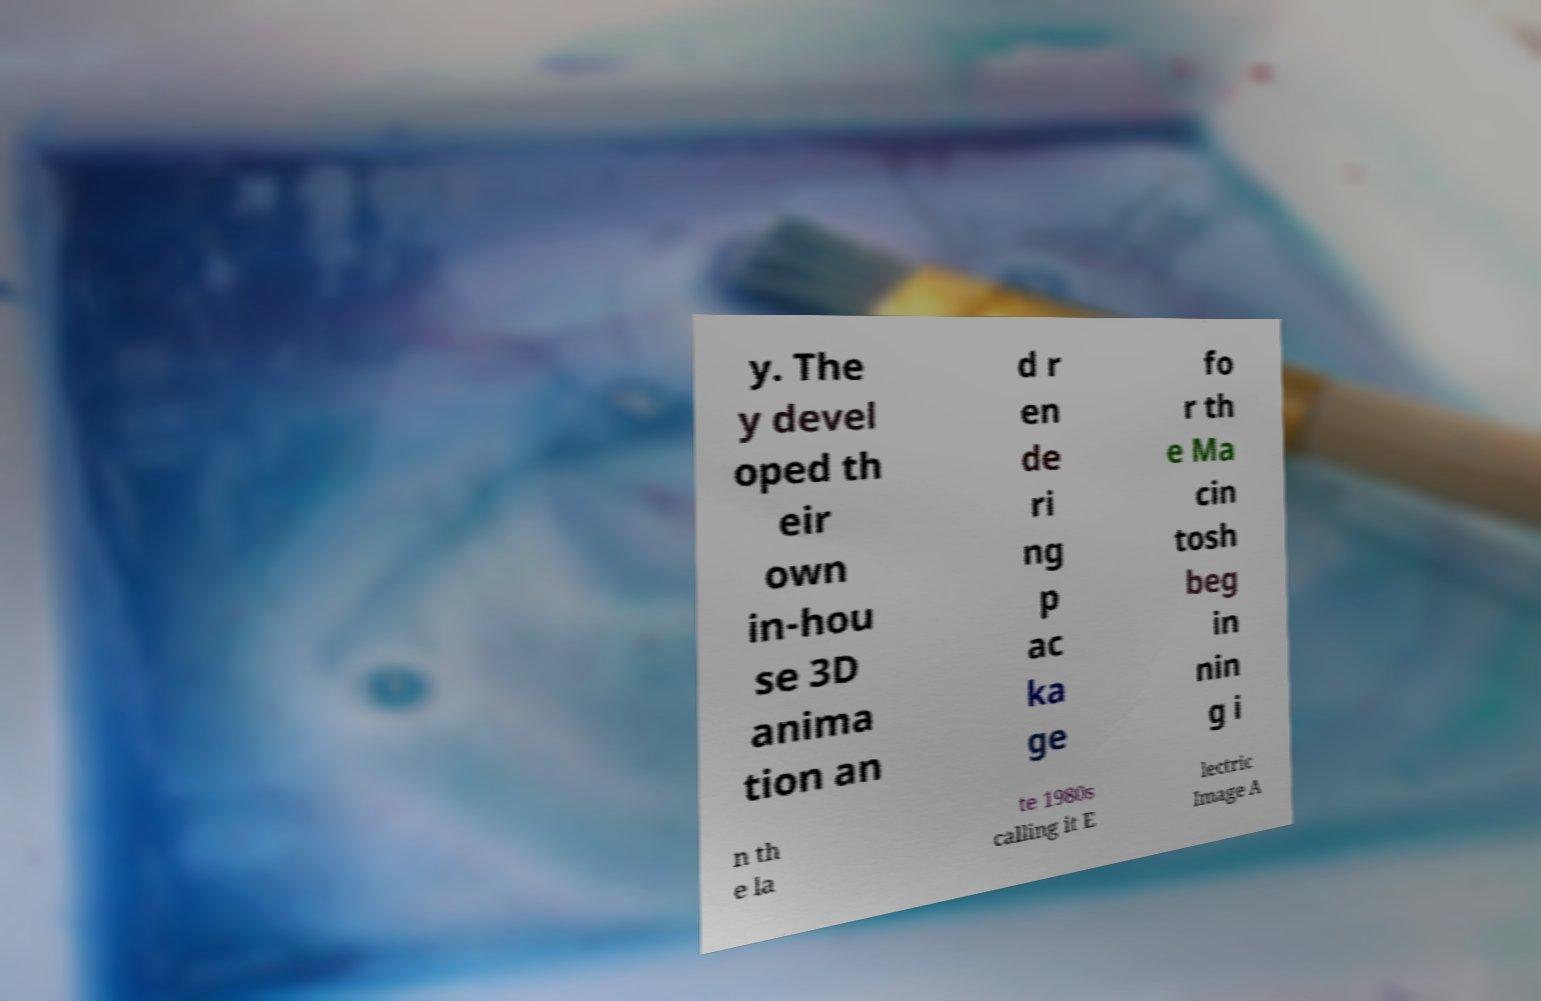Can you read and provide the text displayed in the image?This photo seems to have some interesting text. Can you extract and type it out for me? y. The y devel oped th eir own in-hou se 3D anima tion an d r en de ri ng p ac ka ge fo r th e Ma cin tosh beg in nin g i n th e la te 1980s calling it E lectric Image A 